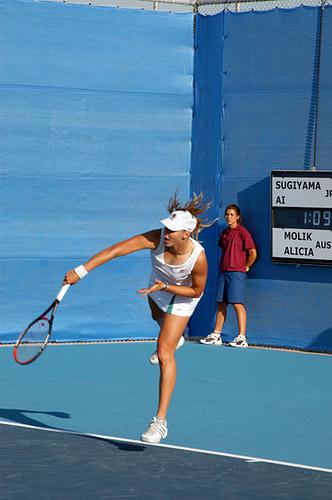Where is the woman playing?
Short answer required. Tennis. What is the woman doing with a racket in the right hand?
Concise answer only. Swinging. Did the tennis player just hit the ball?
Concise answer only. Yes. 